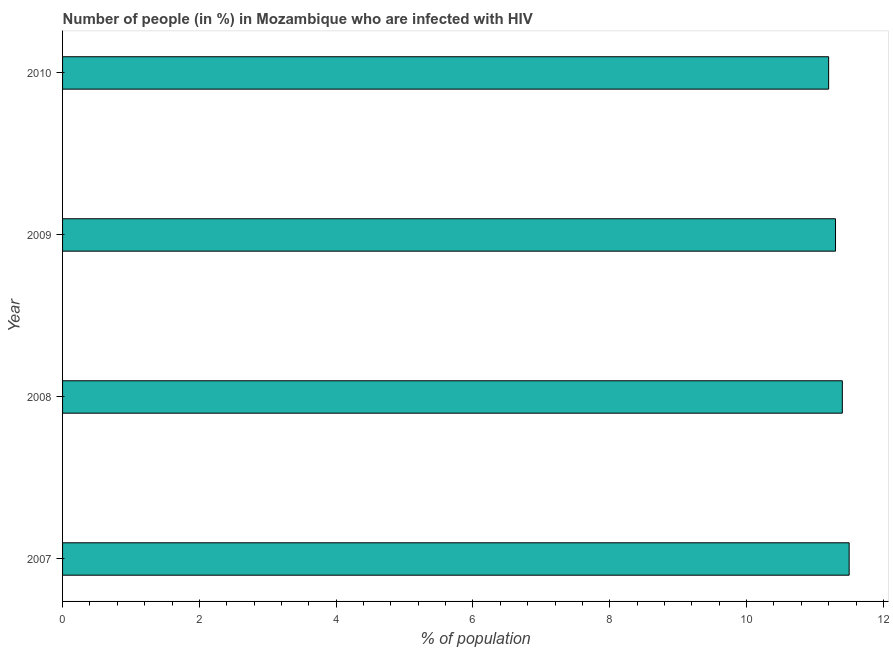What is the title of the graph?
Keep it short and to the point. Number of people (in %) in Mozambique who are infected with HIV. What is the label or title of the X-axis?
Keep it short and to the point. % of population. Across all years, what is the maximum number of people infected with hiv?
Provide a succinct answer. 11.5. In which year was the number of people infected with hiv minimum?
Make the answer very short. 2010. What is the sum of the number of people infected with hiv?
Offer a terse response. 45.4. What is the average number of people infected with hiv per year?
Offer a terse response. 11.35. What is the median number of people infected with hiv?
Provide a succinct answer. 11.35. In how many years, is the number of people infected with hiv greater than 3.6 %?
Provide a succinct answer. 4. Do a majority of the years between 2008 and 2010 (inclusive) have number of people infected with hiv greater than 1.6 %?
Offer a very short reply. Yes. What is the ratio of the number of people infected with hiv in 2007 to that in 2009?
Keep it short and to the point. 1.02. Is the number of people infected with hiv in 2008 less than that in 2009?
Provide a succinct answer. No. Is the difference between the number of people infected with hiv in 2008 and 2010 greater than the difference between any two years?
Keep it short and to the point. No. What is the difference between the highest and the second highest number of people infected with hiv?
Offer a terse response. 0.1. In how many years, is the number of people infected with hiv greater than the average number of people infected with hiv taken over all years?
Make the answer very short. 2. Are all the bars in the graph horizontal?
Your response must be concise. Yes. How many years are there in the graph?
Offer a terse response. 4. What is the difference between two consecutive major ticks on the X-axis?
Provide a succinct answer. 2. What is the % of population in 2007?
Offer a very short reply. 11.5. What is the % of population of 2008?
Keep it short and to the point. 11.4. What is the % of population of 2010?
Your answer should be very brief. 11.2. What is the difference between the % of population in 2007 and 2010?
Ensure brevity in your answer.  0.3. What is the difference between the % of population in 2008 and 2009?
Your answer should be compact. 0.1. What is the difference between the % of population in 2008 and 2010?
Provide a succinct answer. 0.2. What is the difference between the % of population in 2009 and 2010?
Offer a very short reply. 0.1. What is the ratio of the % of population in 2007 to that in 2009?
Make the answer very short. 1.02. What is the ratio of the % of population in 2008 to that in 2009?
Keep it short and to the point. 1.01. What is the ratio of the % of population in 2008 to that in 2010?
Provide a short and direct response. 1.02. 